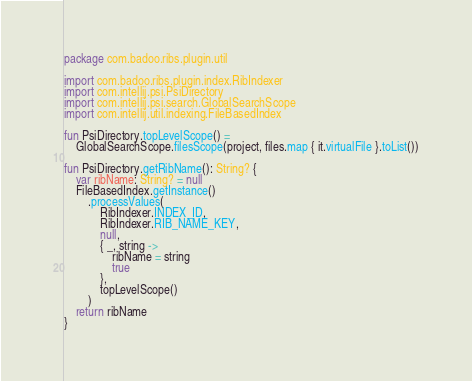Convert code to text. <code><loc_0><loc_0><loc_500><loc_500><_Kotlin_>package com.badoo.ribs.plugin.util

import com.badoo.ribs.plugin.index.RibIndexer
import com.intellij.psi.PsiDirectory
import com.intellij.psi.search.GlobalSearchScope
import com.intellij.util.indexing.FileBasedIndex

fun PsiDirectory.topLevelScope() =
    GlobalSearchScope.filesScope(project, files.map { it.virtualFile }.toList())

fun PsiDirectory.getRibName(): String? {
    var ribName: String? = null
    FileBasedIndex.getInstance()
        .processValues(
            RibIndexer.INDEX_ID,
            RibIndexer.RIB_NAME_KEY,
            null,
            { _, string ->
                ribName = string
                true
            },
            topLevelScope()
        )
    return ribName
}
</code> 